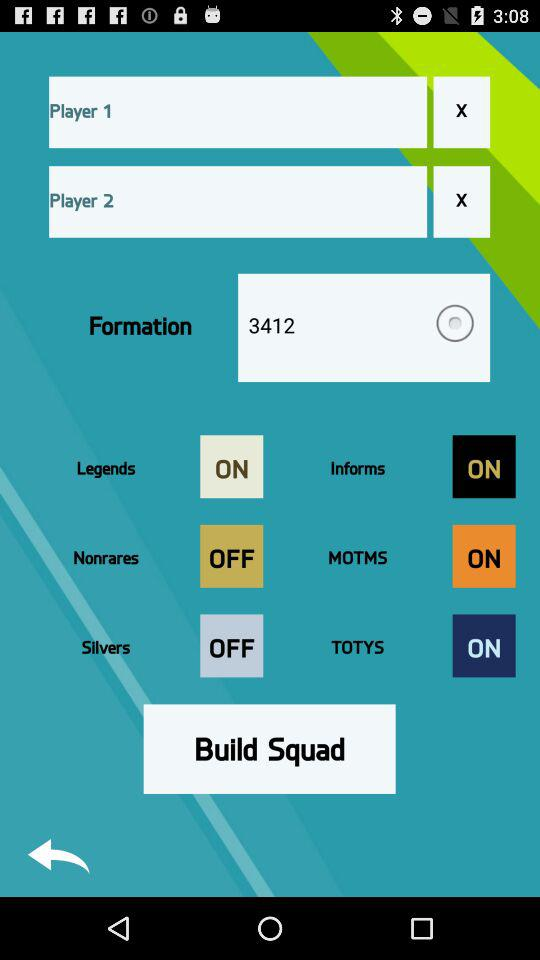What is the number of players?
When the provided information is insufficient, respond with <no answer>. <no answer> 